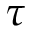<formula> <loc_0><loc_0><loc_500><loc_500>\tau</formula> 